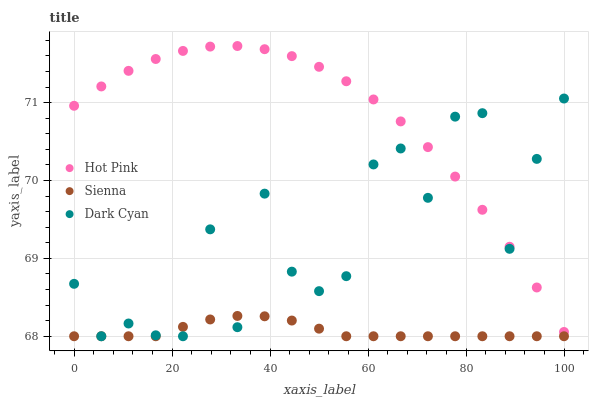Does Sienna have the minimum area under the curve?
Answer yes or no. Yes. Does Hot Pink have the maximum area under the curve?
Answer yes or no. Yes. Does Dark Cyan have the minimum area under the curve?
Answer yes or no. No. Does Dark Cyan have the maximum area under the curve?
Answer yes or no. No. Is Sienna the smoothest?
Answer yes or no. Yes. Is Dark Cyan the roughest?
Answer yes or no. Yes. Is Hot Pink the smoothest?
Answer yes or no. No. Is Hot Pink the roughest?
Answer yes or no. No. Does Sienna have the lowest value?
Answer yes or no. Yes. Does Hot Pink have the lowest value?
Answer yes or no. No. Does Hot Pink have the highest value?
Answer yes or no. Yes. Does Dark Cyan have the highest value?
Answer yes or no. No. Is Sienna less than Hot Pink?
Answer yes or no. Yes. Is Hot Pink greater than Sienna?
Answer yes or no. Yes. Does Sienna intersect Dark Cyan?
Answer yes or no. Yes. Is Sienna less than Dark Cyan?
Answer yes or no. No. Is Sienna greater than Dark Cyan?
Answer yes or no. No. Does Sienna intersect Hot Pink?
Answer yes or no. No. 